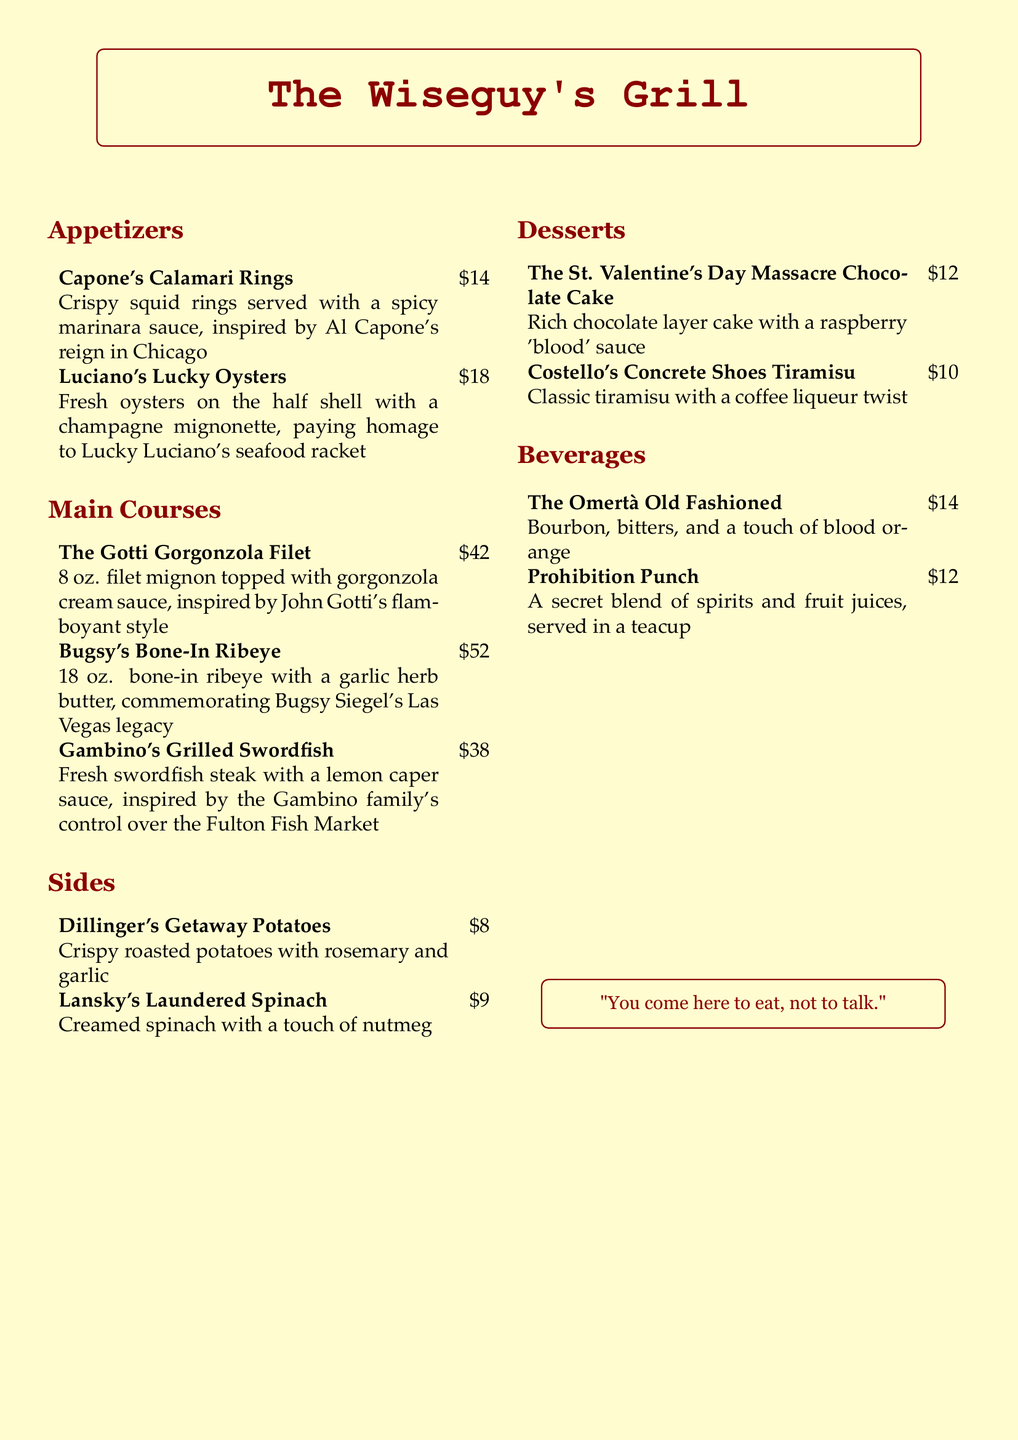what is the name of the restaurant? The name of the restaurant is prominently displayed at the top of the menu.
Answer: The Wiseguy's Grill who is the main inspiration for the "Capone's Calamari Rings"? This dish is inspired by a notorious mobster known for his reign in Chicago.
Answer: Al Capone how much does the "Bugsy's Bone-In Ribeye" cost? The price is listed next to the dish in the main courses section.
Answer: $52 which dessert is themed around a historical event? This dessert references a significant crime event in mob history.
Answer: The St. Valentine's Day Massacre Chocolate Cake what drink features a secret blend of spirits? The drink is noted for its mysterious mix of flavors and serves in a special manner.
Answer: Prohibition Punch which appetizer pays homage to Lucky Luciano? The dish is named after the mobster known for his influence in organized crime.
Answer: Luciano's Lucky Oysters what is the price of the "Dillinger's Getaway Potatoes"? The price is listed under the sides section of the menu.
Answer: $8 which main course features gorgonzola cheese? This dish is topped with a specific creamy cheese and named after a flamboyant mobster.
Answer: The Gotti Gorgonzola Filet what type of seafood is served in the "Gambino's Grilled Swordfish"? The menu specifically highlights this type of fish related to a certain family's business.
Answer: Swordfish 